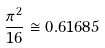<formula> <loc_0><loc_0><loc_500><loc_500>\frac { \pi ^ { 2 } } { 1 6 } \cong 0 . 6 1 6 8 5</formula> 